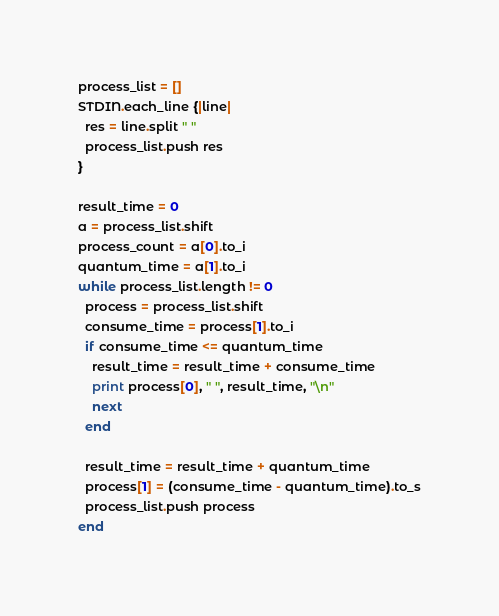<code> <loc_0><loc_0><loc_500><loc_500><_Ruby_>process_list = []
STDIN.each_line {|line|
  res = line.split " "
  process_list.push res
}

result_time = 0
a = process_list.shift
process_count = a[0].to_i
quantum_time = a[1].to_i
while process_list.length != 0
  process = process_list.shift
  consume_time = process[1].to_i
  if consume_time <= quantum_time
    result_time = result_time + consume_time
    print process[0], " ", result_time, "\n"
    next
  end

  result_time = result_time + quantum_time
  process[1] = (consume_time - quantum_time).to_s
  process_list.push process
end
</code> 